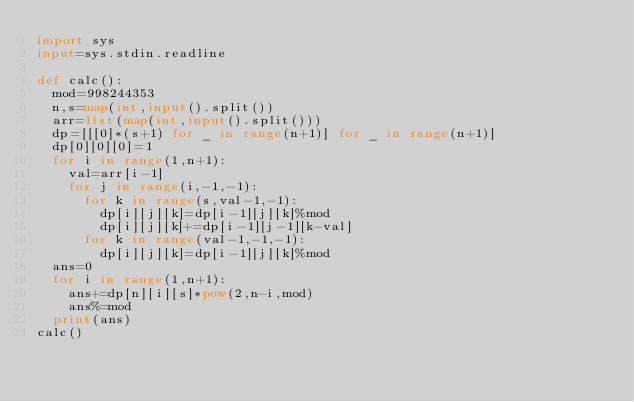Convert code to text. <code><loc_0><loc_0><loc_500><loc_500><_Python_>import sys
input=sys.stdin.readline

def calc():
  mod=998244353
  n,s=map(int,input().split())
  arr=list(map(int,input().split()))
  dp=[[[0]*(s+1) for _ in range(n+1)] for _ in range(n+1)]
  dp[0][0][0]=1
  for i in range(1,n+1):
    val=arr[i-1]
    for j in range(i,-1,-1):
      for k in range(s,val-1,-1):
        dp[i][j][k]=dp[i-1][j][k]%mod
        dp[i][j][k]+=dp[i-1][j-1][k-val]
      for k in range(val-1,-1,-1):
        dp[i][j][k]=dp[i-1][j][k]%mod
  ans=0
  for i in range(1,n+1):
    ans+=dp[n][i][s]*pow(2,n-i,mod)
    ans%=mod
  print(ans)
calc()</code> 